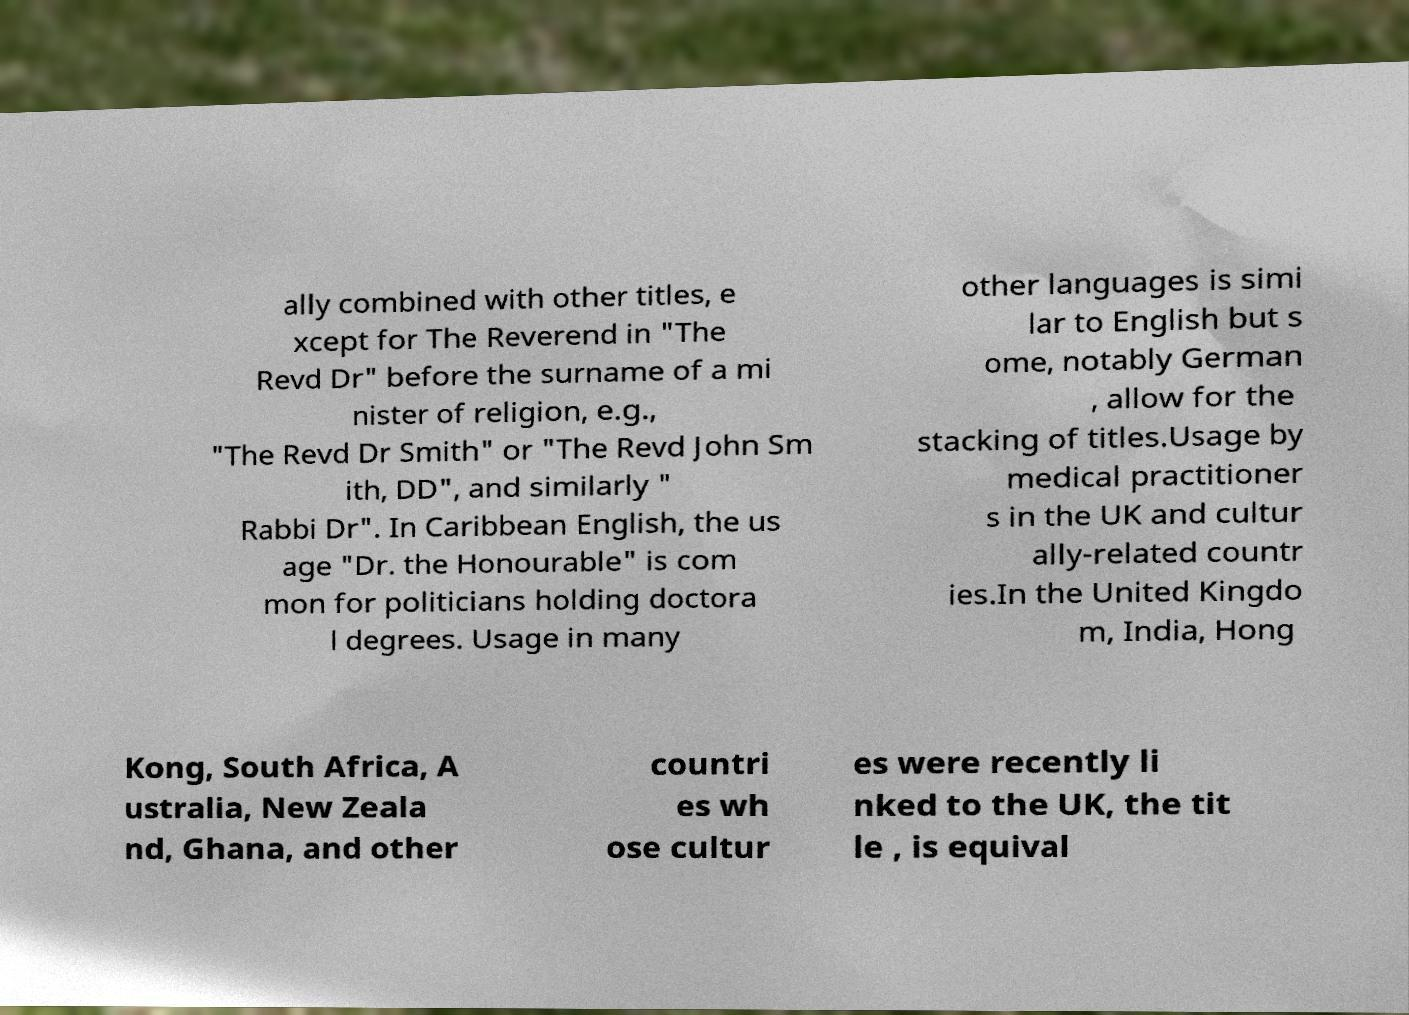What messages or text are displayed in this image? I need them in a readable, typed format. ally combined with other titles, e xcept for The Reverend in "The Revd Dr" before the surname of a mi nister of religion, e.g., "The Revd Dr Smith" or "The Revd John Sm ith, DD", and similarly " Rabbi Dr". In Caribbean English, the us age "Dr. the Honourable" is com mon for politicians holding doctora l degrees. Usage in many other languages is simi lar to English but s ome, notably German , allow for the stacking of titles.Usage by medical practitioner s in the UK and cultur ally-related countr ies.In the United Kingdo m, India, Hong Kong, South Africa, A ustralia, New Zeala nd, Ghana, and other countri es wh ose cultur es were recently li nked to the UK, the tit le , is equival 